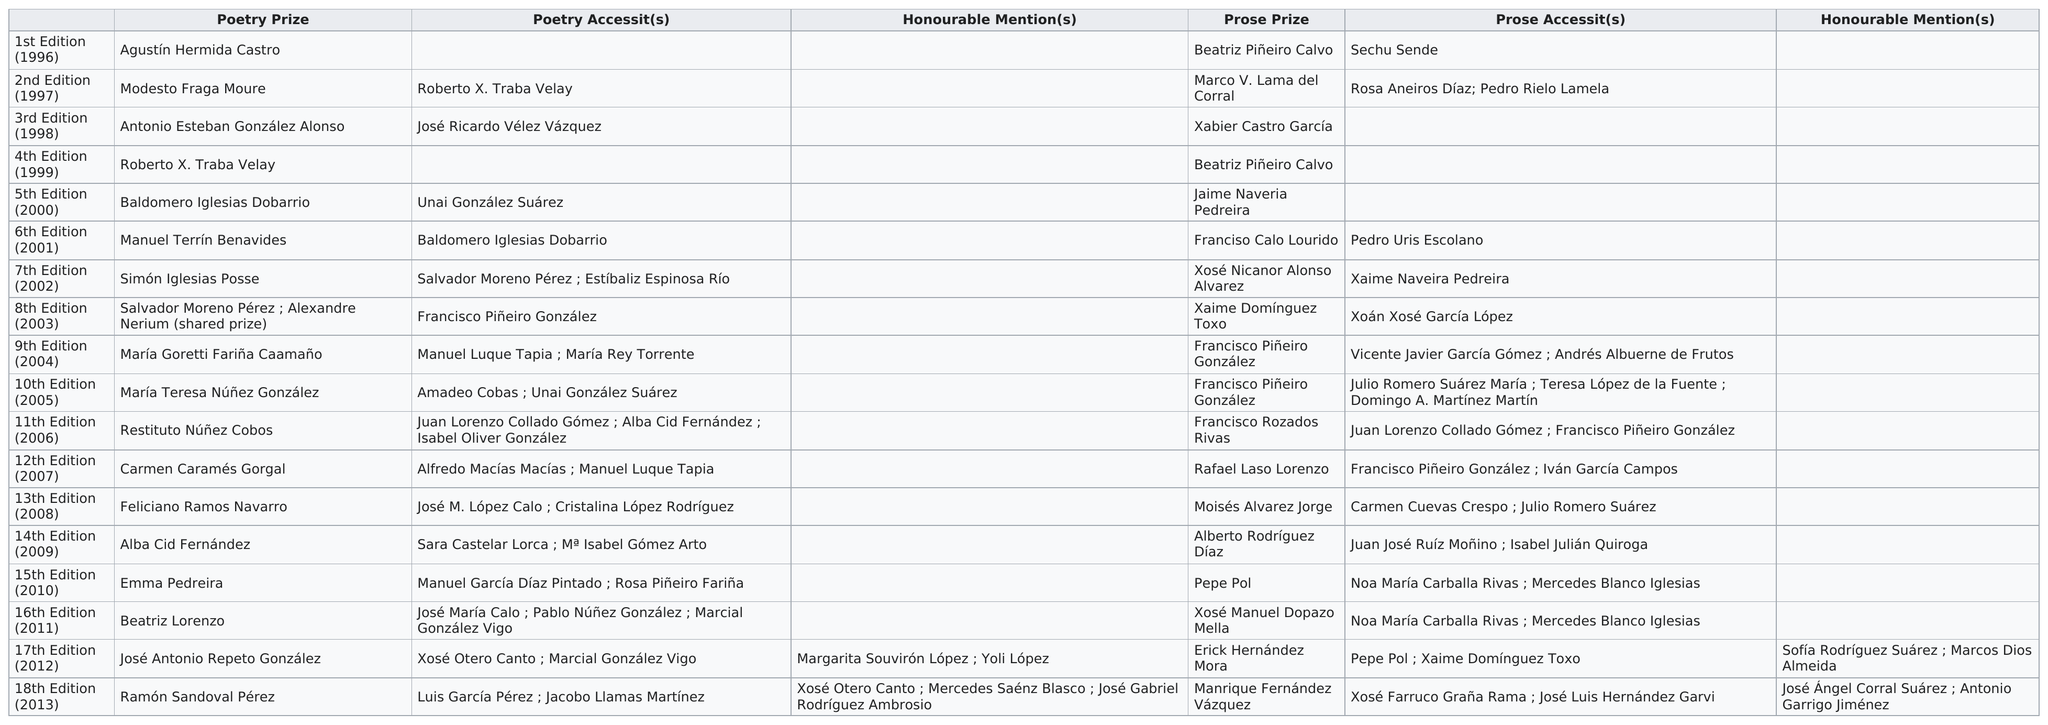Highlight a few significant elements in this photo. The duration in years from the first edition to the 18th edition is 17. The Prose Accessits were awarded to the largest number of people in the year 2005. The poetry prize prior to Emma Pedreira was awarded to Alba Cid Fernández. Each edition of the book does not have more than one poetry prize. The total number of letters used in the last poetry prize was 18. 